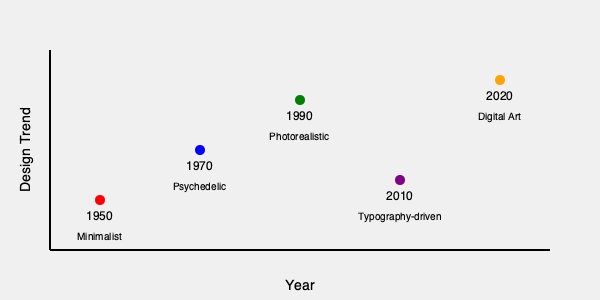Based on the timeline of dust jacket design trends shown in the graph, which period marked a significant shift towards more complex and vibrant visual styles, contrasting with the earlier minimalist approach? To answer this question, we need to analyze the dust jacket design trends presented in the timeline:

1. 1950s: The trend is described as "Minimalist," indicating simple, clean designs with limited colors and graphics.

2. 1970s: The trend is labeled "Psychedelic," which represents a dramatic shift from the minimalist approach. Psychedelic designs are known for:
   - Vibrant, often clashing colors
   - Complex, intricate patterns
   - Fluid, organic forms
   - Experimental typography

3. 1990s: The trend moves to "Photorealistic," suggesting a focus on detailed, lifelike imagery.

4. 2010s: The trend becomes "Typography-driven," indicating a return to simpler designs but with a focus on creative use of text.

5. 2020s: The trend shifts to "Digital Art," implying computer-generated or digitally manipulated imagery.

The most significant shift from minimalism to a more complex and vibrant style occurs in the 1970s with the psychedelic trend. This represents a complete departure from the simple, restrained designs of the 1950s, embracing complexity, color, and visual experimentation.
Answer: 1970s (Psychedelic era) 